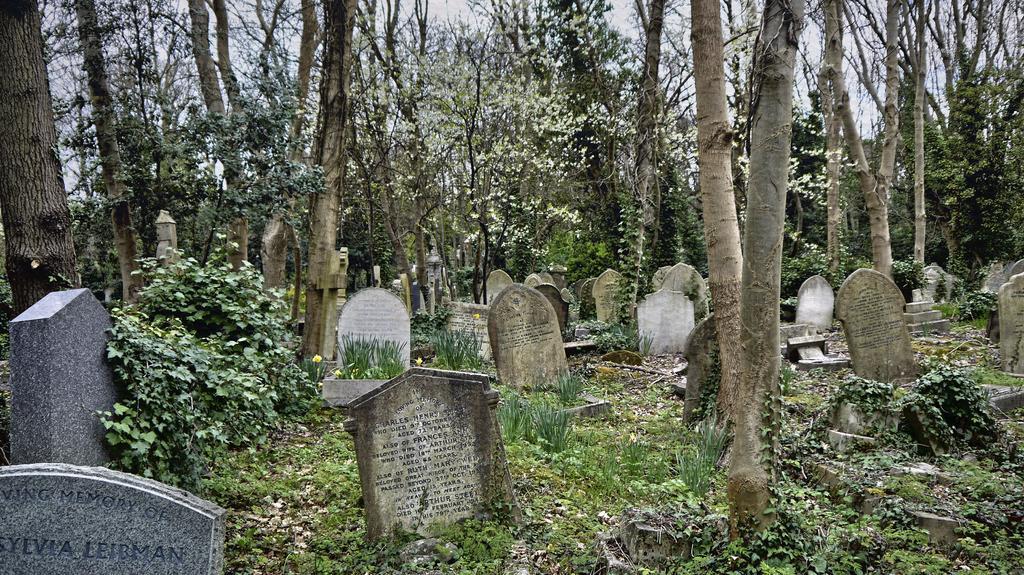How would you summarize this image in a sentence or two? In this picture I can see many graves. In the background I can see many toys, plants and grass. At the top there is a sky 